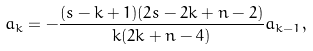<formula> <loc_0><loc_0><loc_500><loc_500>a _ { k } = - \frac { ( s - k + 1 ) ( 2 s - 2 k + n - 2 ) } { k ( 2 k + n - 4 ) } a _ { k - 1 } ,</formula> 